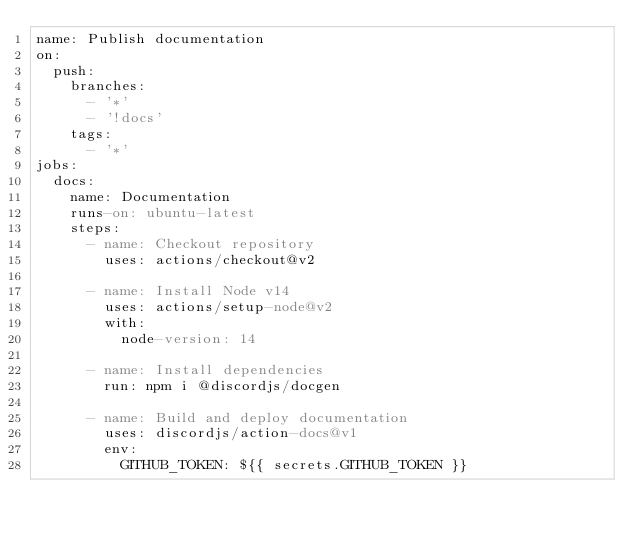<code> <loc_0><loc_0><loc_500><loc_500><_YAML_>name: Publish documentation
on:
  push:
    branches:
      - '*'
      - '!docs'
    tags:
      - '*'
jobs:
  docs:
    name: Documentation
    runs-on: ubuntu-latest
    steps:
      - name: Checkout repository
        uses: actions/checkout@v2

      - name: Install Node v14
        uses: actions/setup-node@v2
        with:
          node-version: 14

      - name: Install dependencies 
        run: npm i @discordjs/docgen 

      - name: Build and deploy documentation
        uses: discordjs/action-docs@v1
        env:
          GITHUB_TOKEN: ${{ secrets.GITHUB_TOKEN }}
</code> 